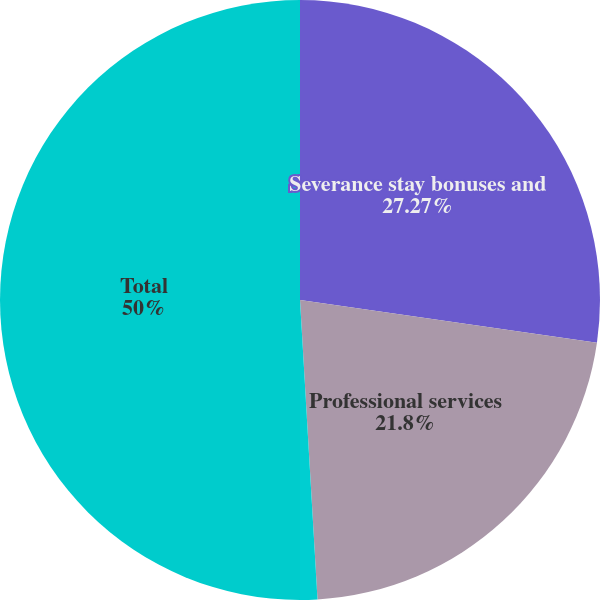Convert chart to OTSL. <chart><loc_0><loc_0><loc_500><loc_500><pie_chart><fcel>Severance stay bonuses and<fcel>Professional services<fcel>Relocation and transition<fcel>Total<nl><fcel>27.27%<fcel>21.8%<fcel>0.93%<fcel>50.0%<nl></chart> 